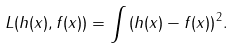<formula> <loc_0><loc_0><loc_500><loc_500>L ( h ( x ) , f ( x ) ) = \int { \left ( h ( x ) - f ( x ) \right ) ^ { 2 } } .</formula> 